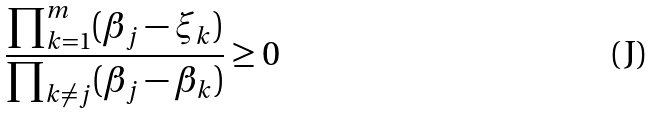<formula> <loc_0><loc_0><loc_500><loc_500>\frac { \prod _ { k = 1 } ^ { m } ( \beta _ { j } - \xi _ { k } ) } { \prod _ { k \neq j } ( \beta _ { j } - \beta _ { k } ) } \geq 0</formula> 